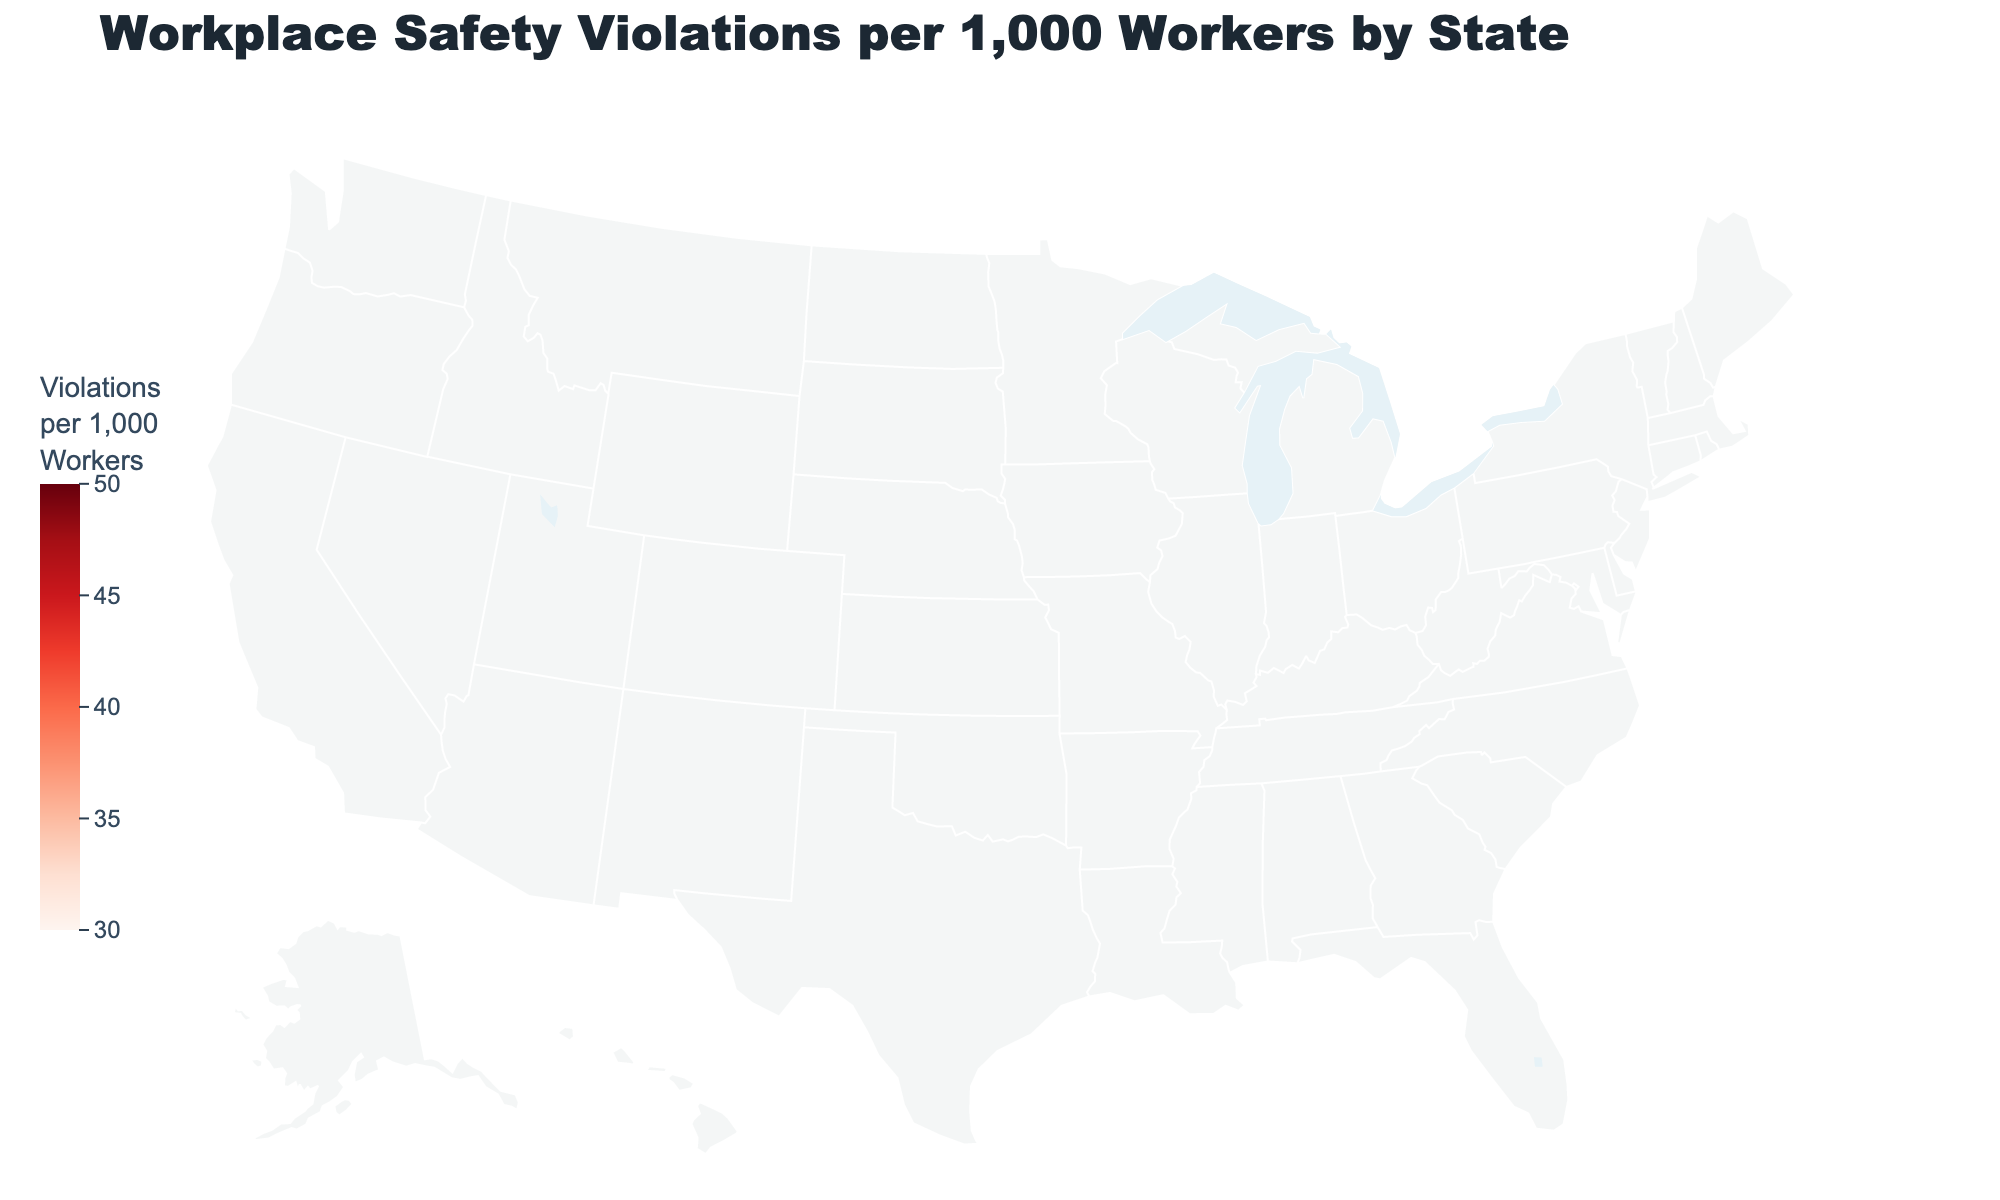what is the title of the plot? The title is the textual element typically displayed at the top of the plot that describes what the plot is about. The title in this figure is "Workplace Safety Violations per 1,000 Workers by State".
Answer: "Workplace Safety Violations per 1,000 Workers by State" How many states have safety violations greater than 40 per 1,000 workers? To determine the number of states with over 40 safety violations per 1,000 workers, count the states with violation values greater than 40. These states are New York, Texas, Pennsylvania, Ohio, Georgia, North Carolina, Arizona, Tennessee, and Indiana. This totals to 9 states.
Answer: 9 Which state has the highest rate of safety violations per 1,000 workers? Find the state with the maximum value in the "Safety_Violations_per_1000_Workers" variable. Tennessee has the highest rate of safety violations at 46.2 per 1,000 workers.
Answer: Tennessee What is the color range used to represent the safety violations? The color range in the plot is typically indicated in the legend or color bar, using different shades to signify varying values. In this plot, the color range is a scale of reds, ranging from light red for lower violation rates to dark red for higher violation rates.
Answer: A scale of reds What can you infer about workplace safety violations in Massachusetts compared to Georgia? Based on the colors and numeric values, Massachusetts has a lower rate of violations (33.5 per 1,000 workers) compared to Georgia (44.7 per 1,000 workers). Massachusetts would be in a lighter shade of red and Georgia in a darker shade.
Answer: Massachusetts has fewer violations per 1,000 workers than Georgia Which states fall below the national average of approximately 40 violations per 1,000 workers? Identify the states with violation rates less than 40.0. These states are California, Illinois, Michigan, Virginia, Washington, Massachusetts, Maryland, Wisconsin, and Colorado.
Answer: California, Illinois, Michigan, Virginia, Washington, Massachusetts, Maryland, Wisconsin, Colorado Compare the workplace safety violations of Ohio and Pennsylvania. Look at the values for Ohio (43.5 violations) and Pennsylvania (40.8 violations). Ohio has a higher rate of workplace safety violations per 1,000 workers than Pennsylvania.
Answer: Ohio has more violations than Pennsylvania What is the difference in safety violations between New York and Washington? Subtract the number of violations in Washington (34.9) from those in New York (42.3). Therefore, the difference is 42.3 - 34.9 = 7.4 violations per 1,000 workers.
Answer: 7.4 What percentage of states have a safety violation rate below 38 per 1,000 workers? Count the states with violations below 38 (Illinois, Washington, Massachusetts, Wisconsin, and Colorado) and divide by the total number of states (20), then multiply by 100. The calculation is (5/20) * 100 = 25%.
Answer: 25% What are the safety violation rates for Florida and Texas, and which state has a higher rate? The rate for Florida is 39.6 per 1,000 workers, and for Texas, it is 45.1 per 1,000 workers. Texas has a higher rate of workplace safety violations than Florida.
Answer: Texas 